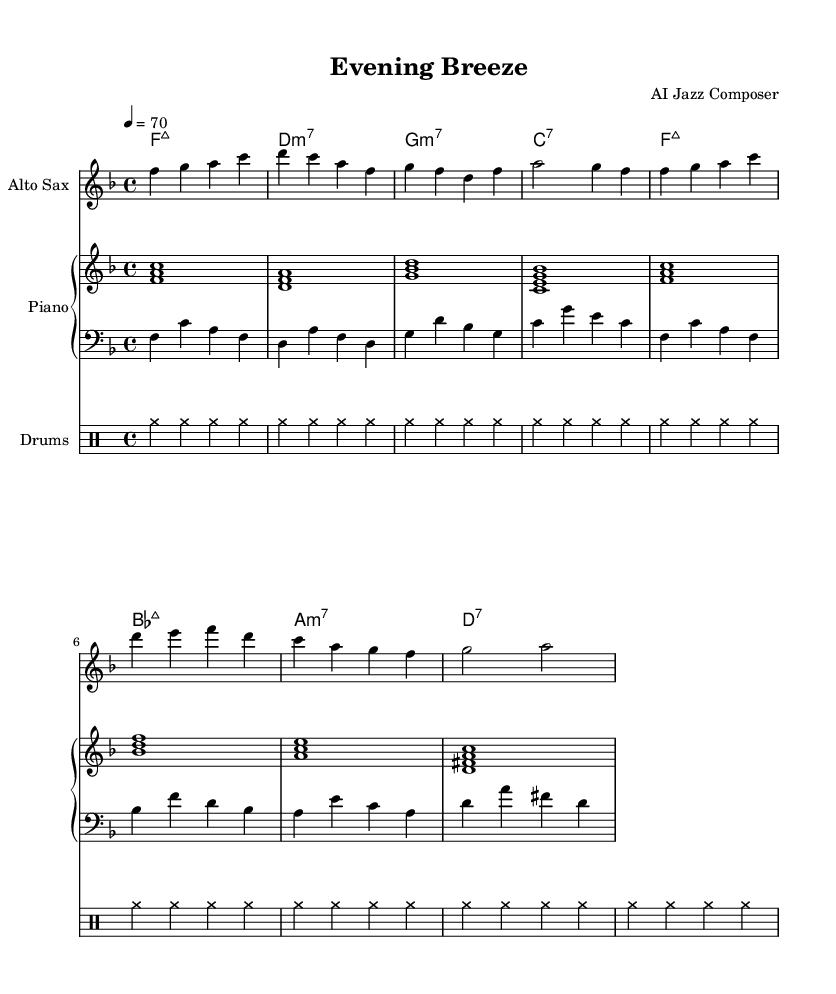What is the key signature of this music? The key signature is F major, which has one flat (B flat). This can be determined by observing the key signature indicated at the beginning of the score.
Answer: F major What is the time signature of this music? The time signature is 4/4, as indicated at the beginning of the score. The denominator shows that there are four beats in each measure, and the numerator indicates that the quarter note gets one beat.
Answer: 4/4 What is the tempo marking for this piece? The tempo marking is quarter note equals seventy, which specifies the speed of the music. This is found under the tempo directive at the beginning of the score.
Answer: 70 How many measures are in the saxophone part? There are eight measures in the saxophone part, as indicated by the bar lines that separate each measure in the staff. The measures can be counted individually from the start to the end of the saxophone section.
Answer: 8 What type of seventh chord is the first chord played by the piano? The first chord is an F major seventh chord. This can be identified by recognizing the notes in the chord (F, A, C, E) that correspond to the F major seventh chord structure.
Answer: major7 How many repeated drum strokes are in one section of the drum pattern? There are seven repeated drum strokes in one section, as noted by the repeat indicator and the description of the rhythm pattern. Each section shows a repetition of cymbal hits which comprise the complete rhythmic cycle.
Answer: 7 What is the last note played by the alto saxophone? The last note played by the alto saxophone is an A. This can be deduced from the notated pitch at the end of the saxophone part on the staff.
Answer: A 